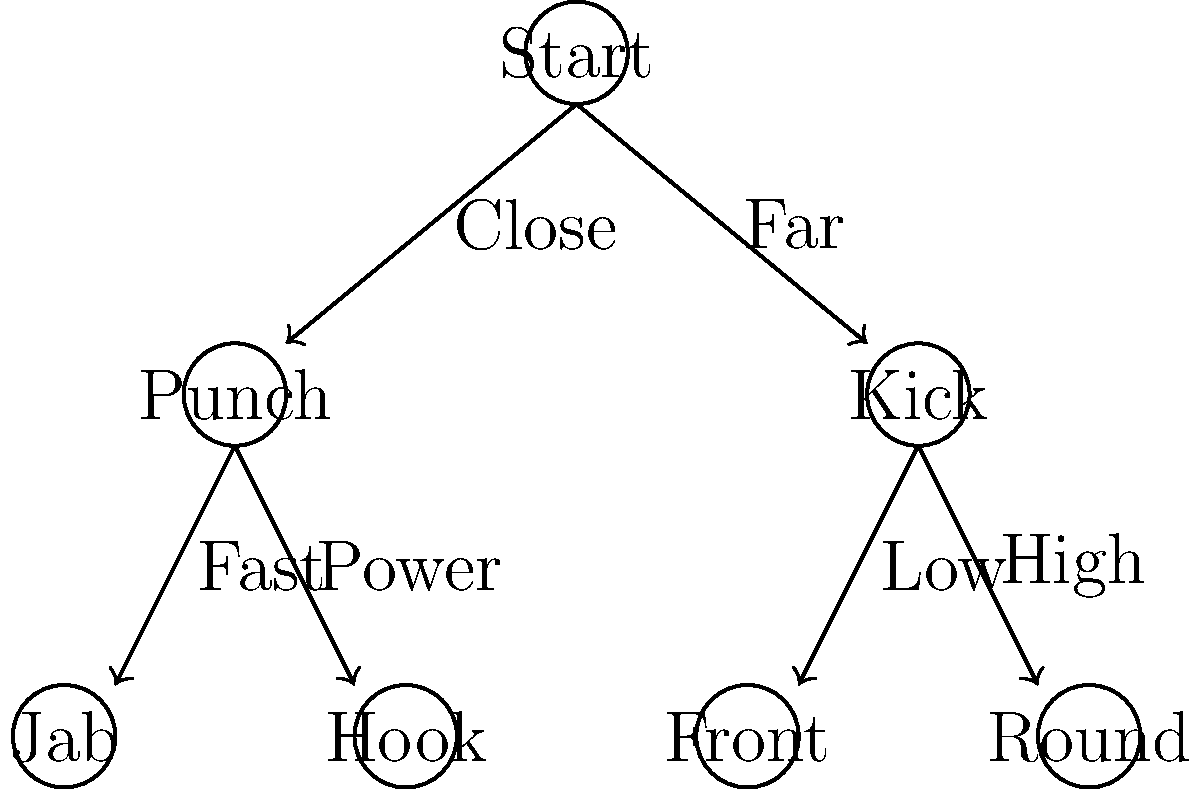In a mixed martial arts fight, you need to quickly decide on the best counterattack based on your opponent's position and movement. Using the decision tree above, which technique would you choose if your opponent is at a close range and you want to deliver a fast strike? To determine the best counterattack using the decision tree, we'll follow these steps:

1. Start at the root node "Start".

2. Assess the opponent's distance:
   - The first branch splits into "Close" and "Far".
   - Since the opponent is at close range, we follow the "Close" branch.

3. This leads us to the "Punch" node, indicating that punching techniques are more suitable for close-range combat.

4. From the "Punch" node, we have two options:
   - "Fast" leading to "Jab"
   - "Power" leading to "Hook"

5. The question specifies that we want to deliver a fast strike.
   - We follow the "Fast" branch.

6. This leads us to the "Jab" technique, which is indeed a fast punching technique commonly used in close-range situations.

Therefore, based on the decision tree and the given scenario (close range and fast strike), the best counterattack technique would be a jab.
Answer: Jab 